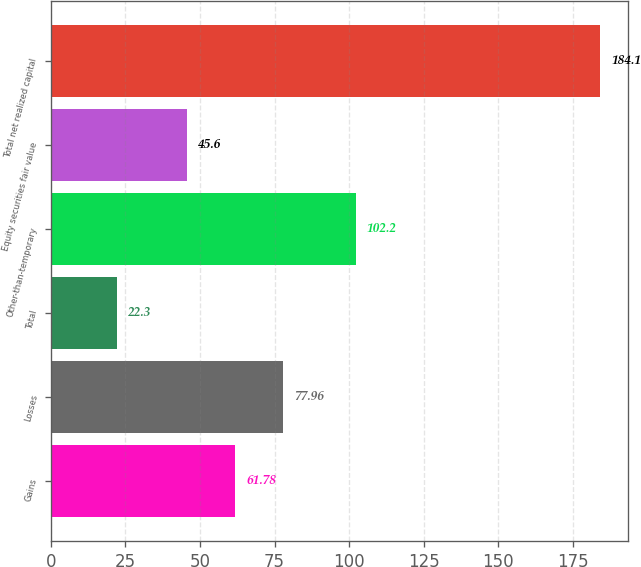Convert chart to OTSL. <chart><loc_0><loc_0><loc_500><loc_500><bar_chart><fcel>Gains<fcel>Losses<fcel>Total<fcel>Other-than-temporary<fcel>Equity securities fair value<fcel>Total net realized capital<nl><fcel>61.78<fcel>77.96<fcel>22.3<fcel>102.2<fcel>45.6<fcel>184.1<nl></chart> 